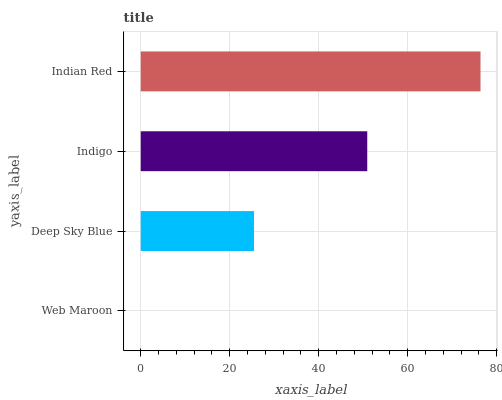Is Web Maroon the minimum?
Answer yes or no. Yes. Is Indian Red the maximum?
Answer yes or no. Yes. Is Deep Sky Blue the minimum?
Answer yes or no. No. Is Deep Sky Blue the maximum?
Answer yes or no. No. Is Deep Sky Blue greater than Web Maroon?
Answer yes or no. Yes. Is Web Maroon less than Deep Sky Blue?
Answer yes or no. Yes. Is Web Maroon greater than Deep Sky Blue?
Answer yes or no. No. Is Deep Sky Blue less than Web Maroon?
Answer yes or no. No. Is Indigo the high median?
Answer yes or no. Yes. Is Deep Sky Blue the low median?
Answer yes or no. Yes. Is Web Maroon the high median?
Answer yes or no. No. Is Indian Red the low median?
Answer yes or no. No. 